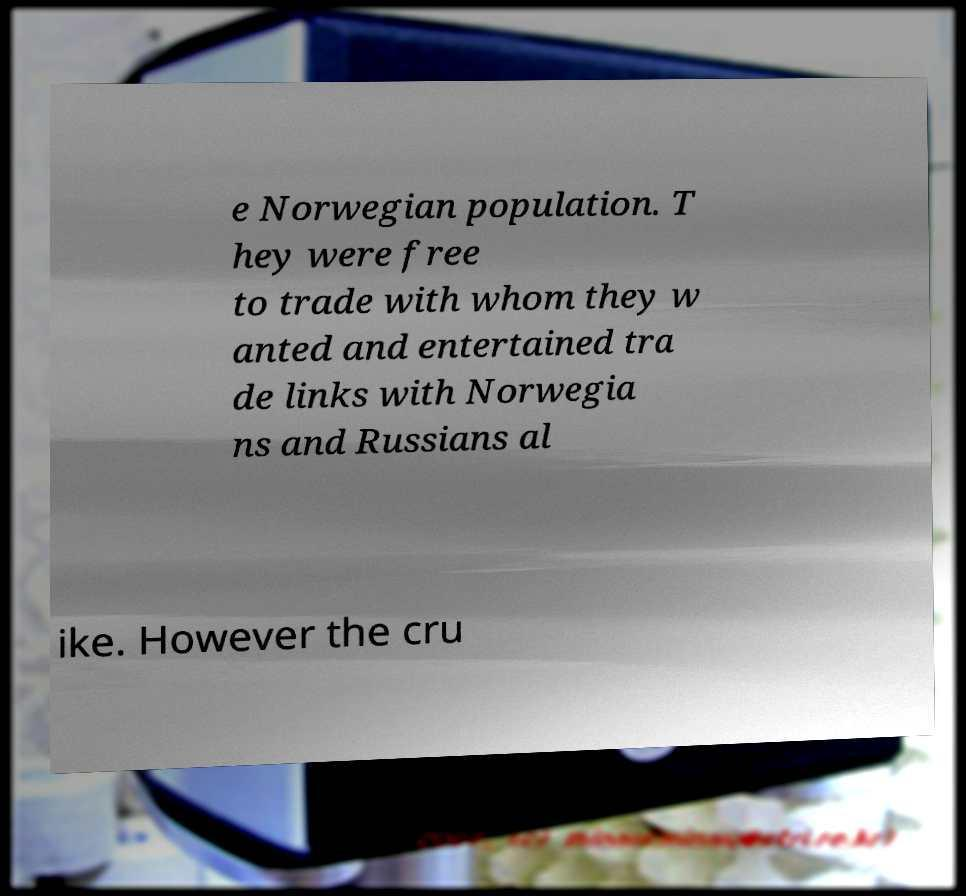There's text embedded in this image that I need extracted. Can you transcribe it verbatim? e Norwegian population. T hey were free to trade with whom they w anted and entertained tra de links with Norwegia ns and Russians al ike. However the cru 